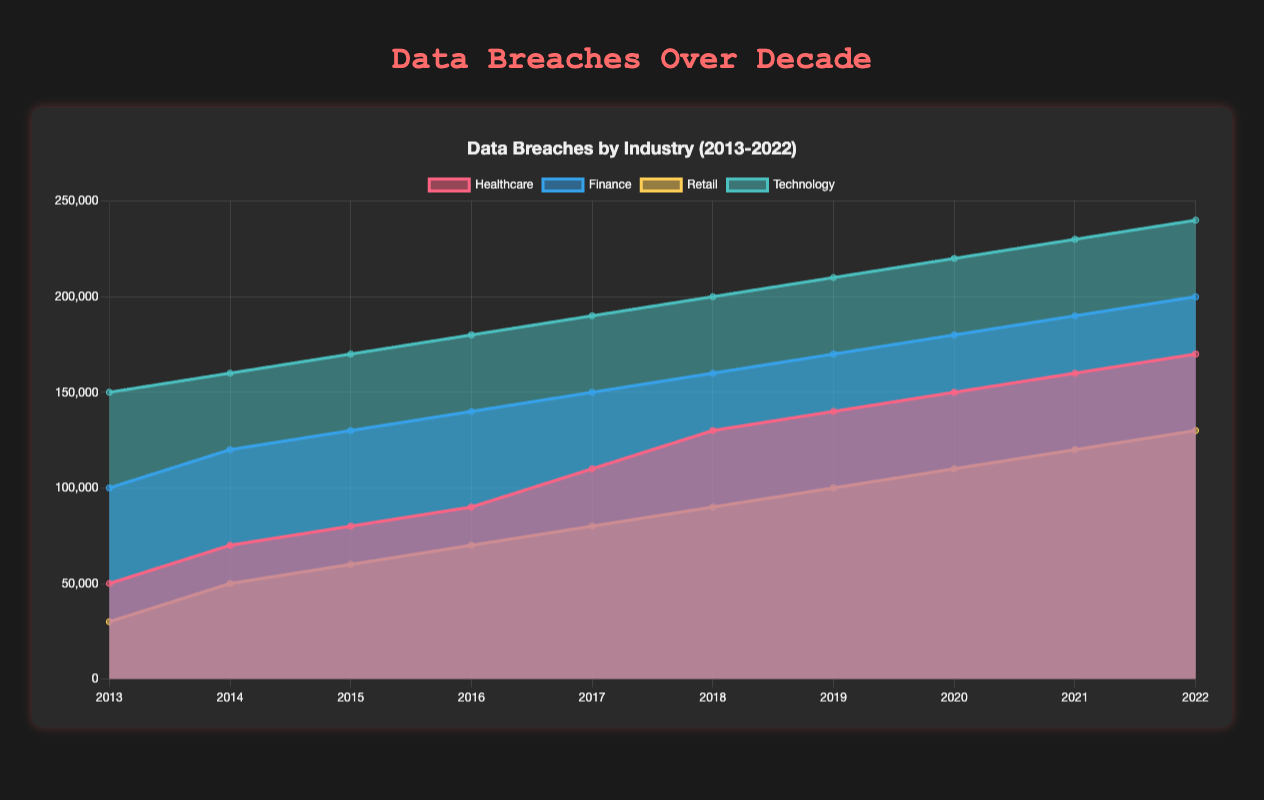what is the title of the figure? The title is typically placed at the top of the chart. In this case, it is "Data Breaches by Industry (2013-2022)" since that text is specified in the configuration.
Answer: Data Breaches by Industry (2013-2022) which industry had the highest data breaches in 2017? By looking at the data points in the 2017 section, Technology has the highest value of 190,000 compared to Healthcare, Finance, and Retail.
Answer: Technology how does the number of data breaches in 2013 for Healthcare compare to 2022? The Healthcare industry had 50,000 data breaches in 2013 and 170,000 in 2022, showing an increase of 120,000 over the decade.
Answer: Increased by 120,000 which industry shows the most consistent rise in data breaches from 2013 to 2022? From the figure, all industries show a consistent increase, but Technology shows a more steady and linear increase without any dips from 150,000 in 2013 to 240,000 in 2022.
Answer: Technology how many total data breaches were there in the Finance sector over the decade? Adding the breaches from each year: 100,000 (2013) + 120,000 (2014) + 130,000 (2015) + 140,000 (2016) + 150,000 (2017) + 160,000 (2018) + 170,000 (2019) + 180,000 (2020) + 190,000 (2021) + 200,000 (2022) equals 1,540,000 breaches.
Answer: 1,540,000 what is the trend for Retail data breaches from 2013 to 2022? The Retail sector shows a consistent upward trend from 30,000 breaches in 2013 to 130,000 breaches in 2022, indicating a continuous increase over the years.
Answer: Upward trend between 2016 and 2018, which industry had the smallest increase in data breaches? Calculating the differences: Healthcare (130,000 - 90,000 = 40,000), Finance (160,000 - 140,000 = 20,000), Retail (90,000 - 70,000 = 20,000), and Technology (200,000 - 180,000 = 20,000). Retail, Finance, and Technology all had a 20,000 increase, which is the smallest.
Answer: Retail, Finance, and Technology during which year did the Healthcare industry breach count exceed 150,000? Examining the values, the Healthcare sector first exceeds 150,000 breaches in the year 2020 reaching exactly 150,000.
Answer: 2020 how does the breach count in 2020 compare across all industries? In 2020, checking the data values, the breaches are: Healthcare (150,000), Finance (180,000), Retail (110,000), Technology (220,000). Technology had the highest and Retail had the lowest breaches.
Answer: Technology: highest, Retail: lowest 